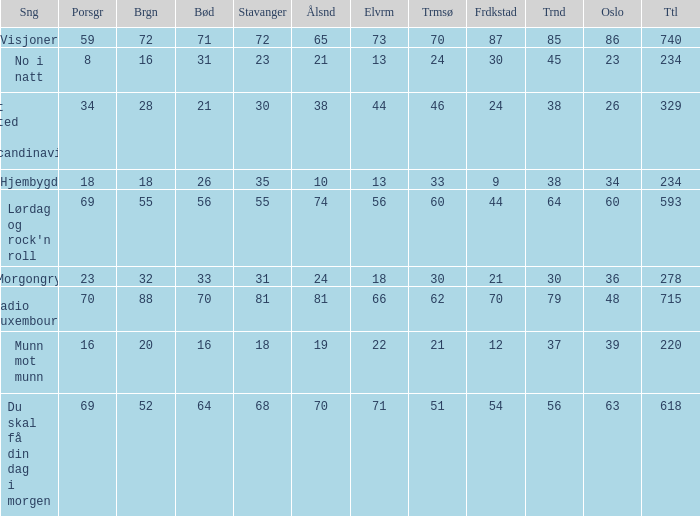What was the total for radio luxembourg? 715.0. 